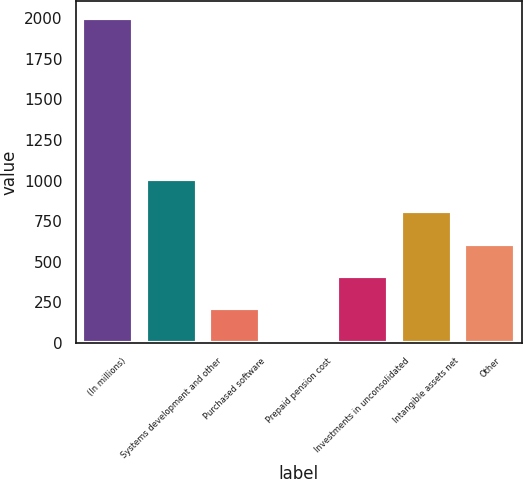<chart> <loc_0><loc_0><loc_500><loc_500><bar_chart><fcel>(In millions)<fcel>Systems development and other<fcel>Purchased software<fcel>Prepaid pension cost<fcel>Investments in unconsolidated<fcel>Intangible assets net<fcel>Other<nl><fcel>2003<fcel>1010<fcel>215.6<fcel>17<fcel>414.2<fcel>811.4<fcel>612.8<nl></chart> 